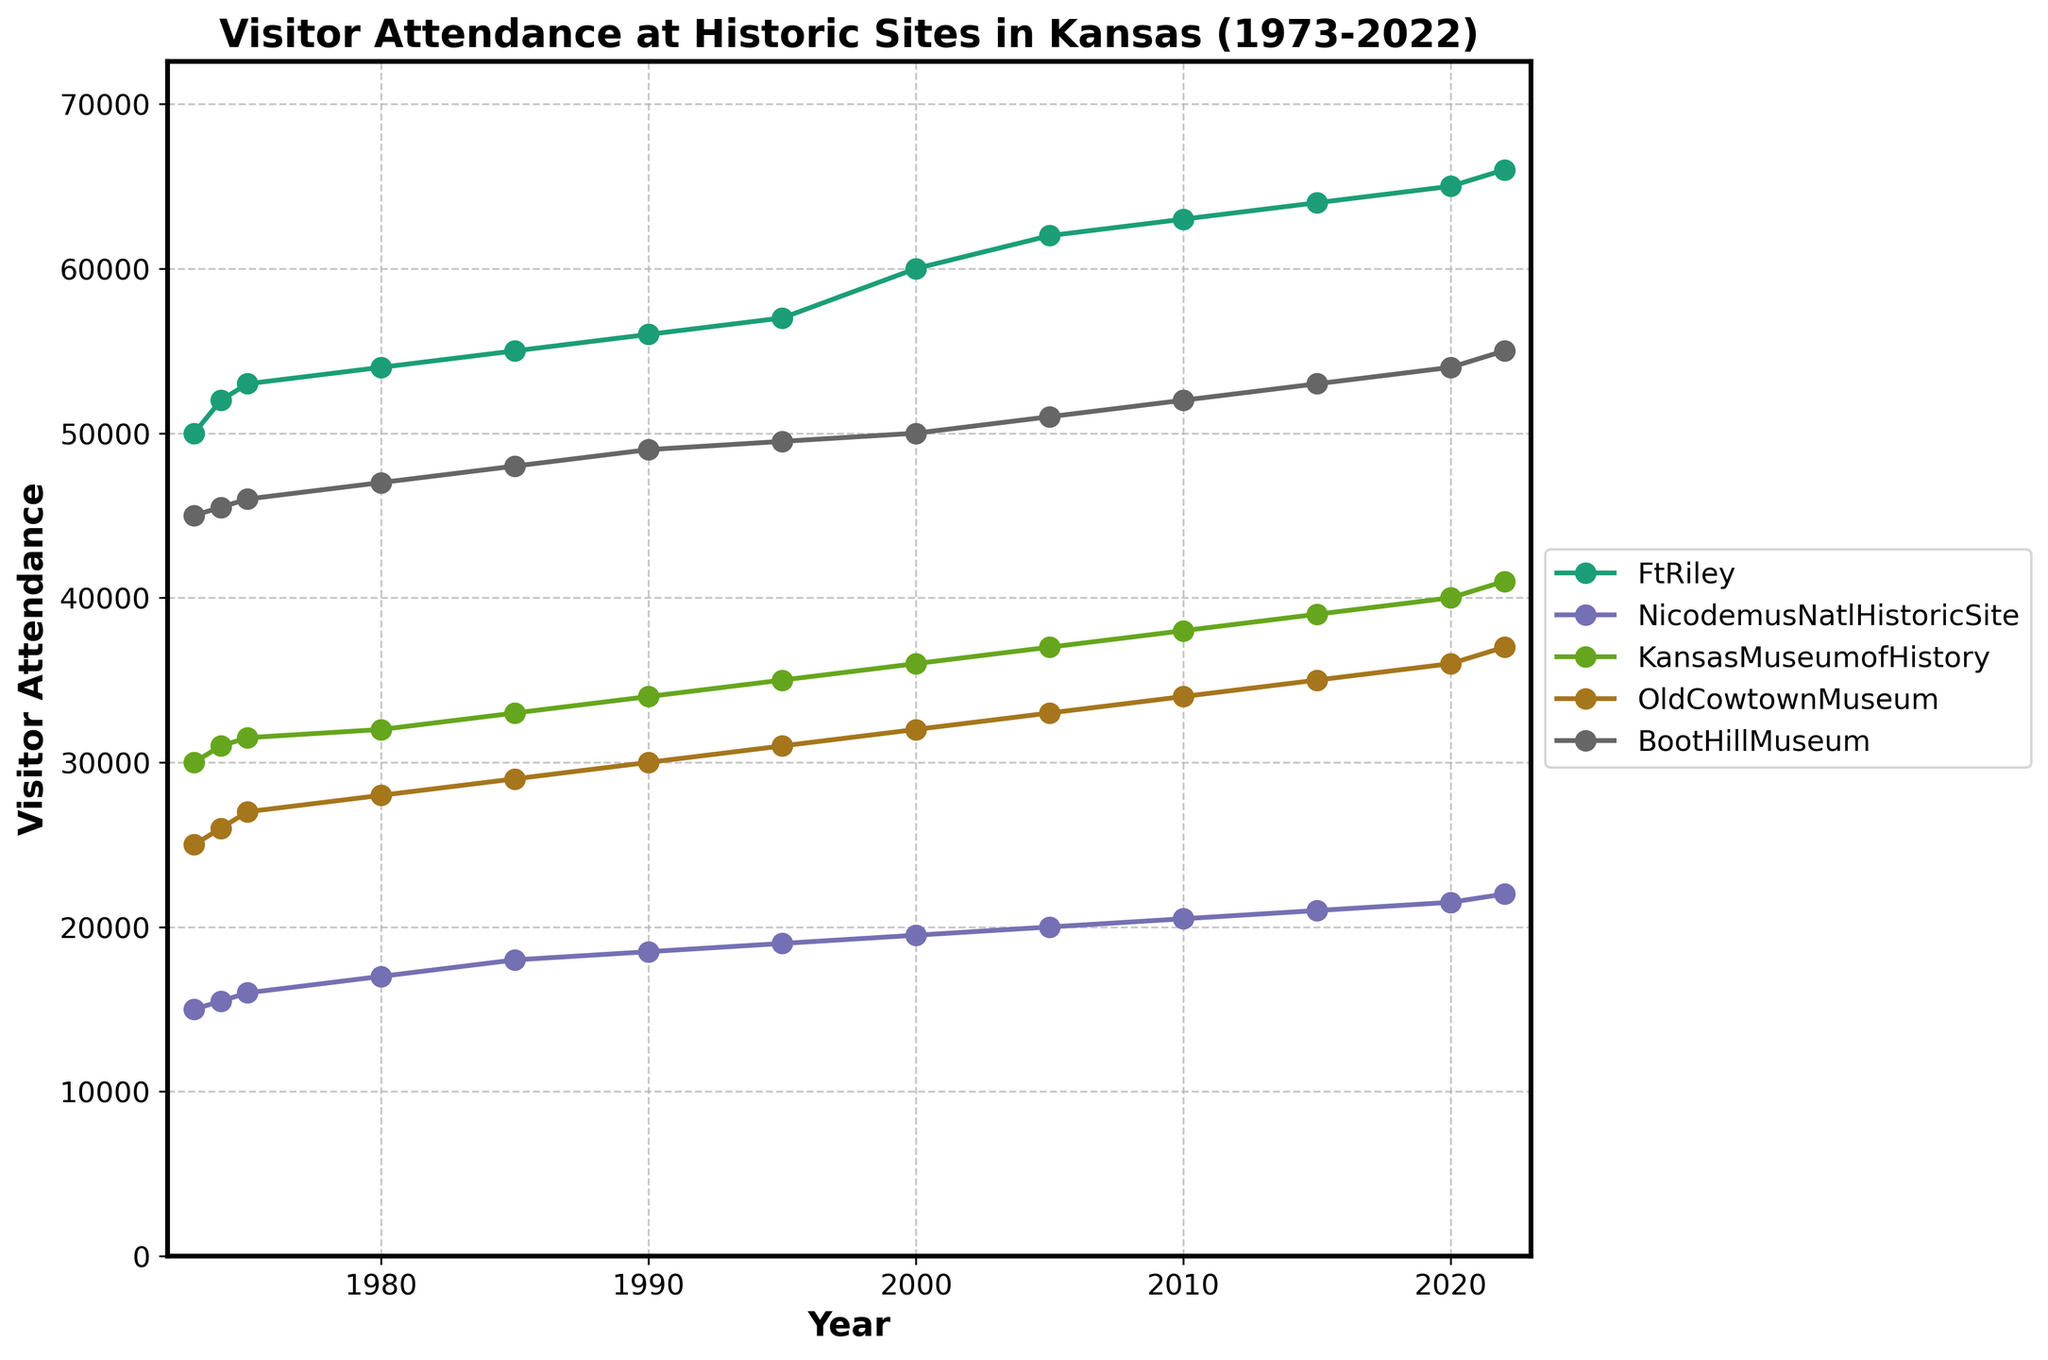What is the title of the plot? The title is displayed at the top of the figure. It is meant to give a brief idea about the data being represented.
Answer: Visitor Attendance at Historic Sites in Kansas (1973-2022) Which site had the highest visitor attendance in 2022? Looking at the last data point for each series in the plot, find the one with the highest value.
Answer: Boot Hill Museum What is the trend in visitor attendance at the Kansas Museum of History from 1973 to 2022? Examine the line representing the Kansas Museum of History from the start to the end of the period. Note the overall direction of the line.
Answer: Increasing How many sites have an attendance greater than 40,000 in 2022? Identify the 2022 data points for each site, and count the ones above 40,000.
Answer: Five Which site had the smallest increase in visitor attendance from 1973 to 2022? For each site, subtract the attendance in 1973 from the attendance in 2022 and find the site with the smallest difference.
Answer: Nicodemus National Historic Site Which years show the highest attendance growth for Boot Hill Museum? By looking at the slope of the lines, identify the period where the line representing Boot Hill Museum shows the steepest positive slope.
Answer: 1973-1985 Is there any site that shows a decrease in visitor attendance over the years? Review the lines on the plot to see if any of them slope downward at any point, indicating a decrease in visitor attendance.
Answer: No What is the average visitor attendance at Old Cowtown Museum from 1980 to 2000? Identify the data points for Old Cowtown Museum for the years 1980, 1985, 1990, 1995, and 2000, sum them up and divide by the number of data points.
Answer: 30000 